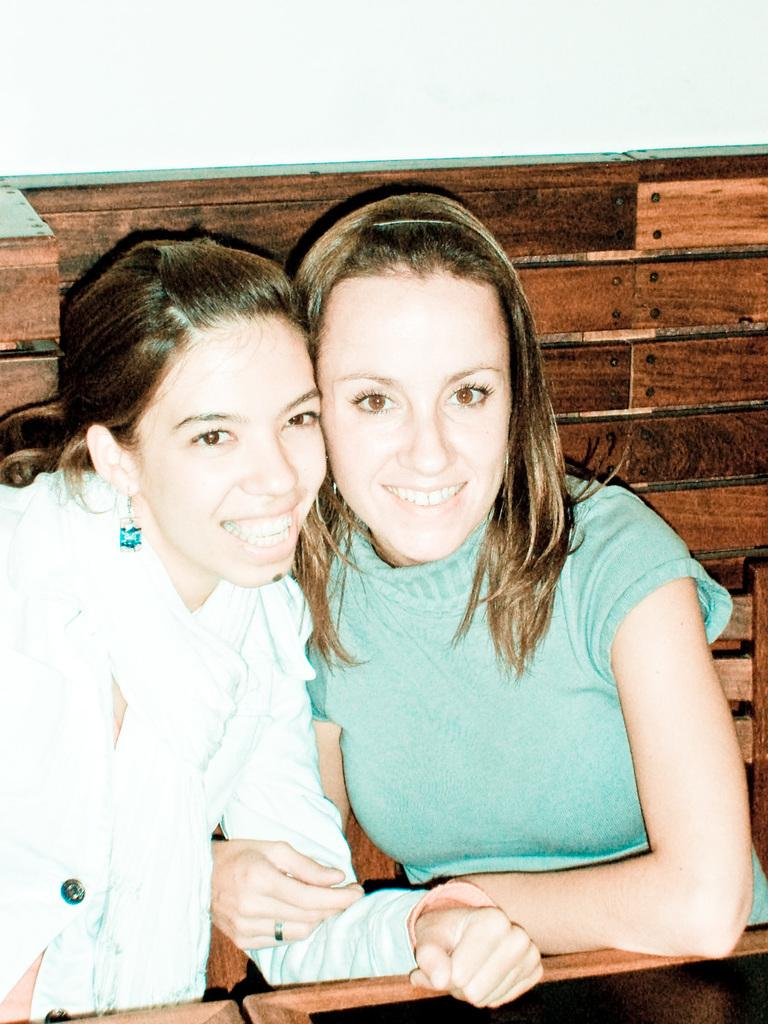How many people are in the image? There are two women in the image. What is the facial expression of the women in the image? The women are smiling. What can be seen in the background of the image? There is a wall in the background of the image. What type of animal can be seen at the zoo in the image? There is no zoo or animal present in the image; it features two women smiling. Can you tell me how the brother of one of the women is helping her in the image? There is no brother or any indication of help being provided in the image. 